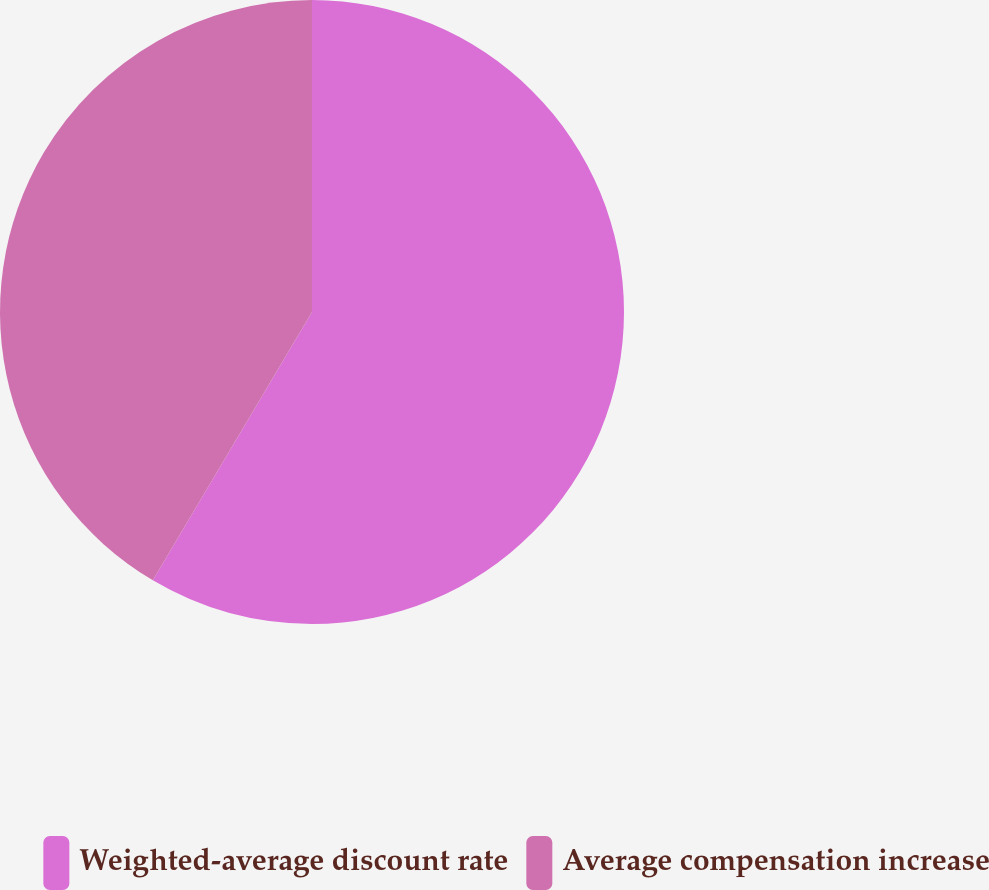Convert chart. <chart><loc_0><loc_0><loc_500><loc_500><pie_chart><fcel>Weighted-average discount rate<fcel>Average compensation increase<nl><fcel>58.52%<fcel>41.48%<nl></chart> 